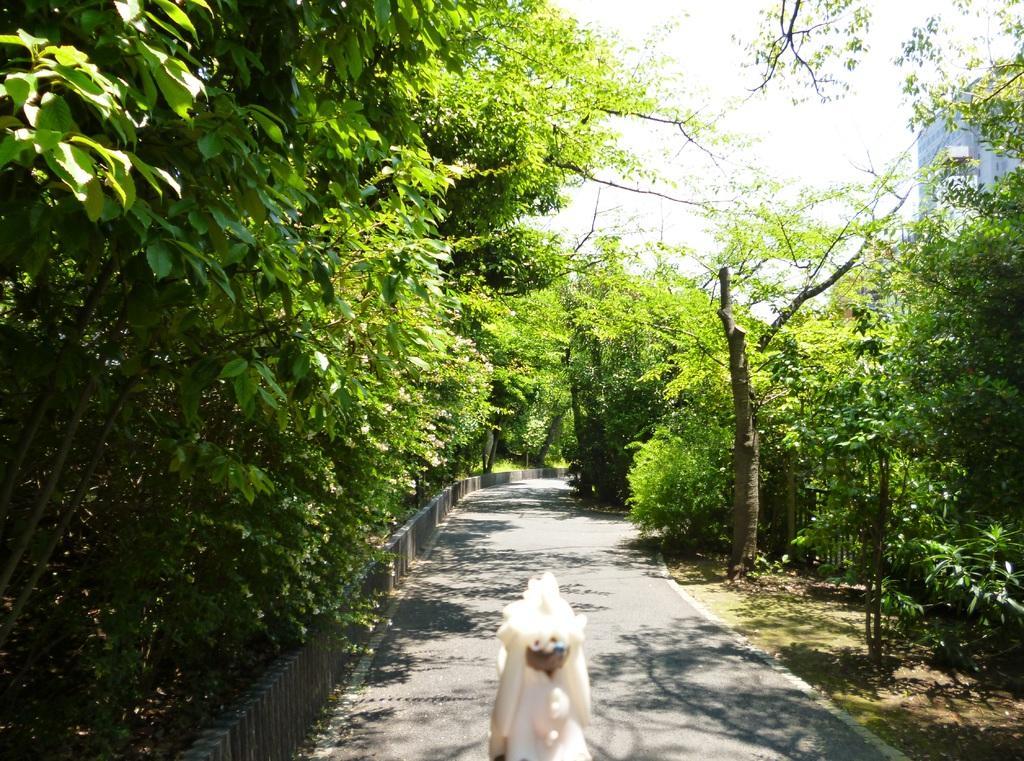How would you summarize this image in a sentence or two? In this image there is an object, road, trees, plants, building, sky. 